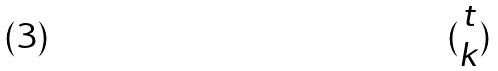<formula> <loc_0><loc_0><loc_500><loc_500>( \begin{matrix} t \\ k \end{matrix} )</formula> 